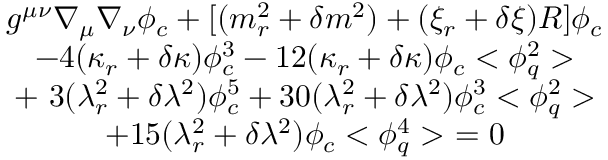Convert formula to latex. <formula><loc_0><loc_0><loc_500><loc_500>\begin{array} { c } { { g ^ { \mu \nu } \nabla _ { \mu } \nabla _ { \nu } \phi _ { c } + [ ( m _ { r } ^ { 2 } + \delta m ^ { 2 } ) + ( \xi _ { r } + \delta \xi ) R ] \phi _ { c } } } \\ { { - 4 ( \kappa _ { r } + \delta \kappa ) \phi _ { c } ^ { 3 } - 1 2 ( \kappa _ { r } + \delta \kappa ) \phi _ { c } < \phi _ { q } ^ { 2 } > } } \\ { { + \ 3 ( \lambda _ { r } ^ { 2 } + \delta \lambda ^ { 2 } ) \phi _ { c } ^ { 5 } + 3 0 ( \lambda _ { r } ^ { 2 } + \delta \lambda ^ { 2 } ) \phi _ { c } ^ { 3 } < \phi _ { q } ^ { 2 } > } } \\ { { + 1 5 ( \lambda _ { r } ^ { 2 } + \delta \lambda ^ { 2 } ) \phi _ { c } < \phi _ { q } ^ { 4 } > \ = 0 } } \end{array}</formula> 